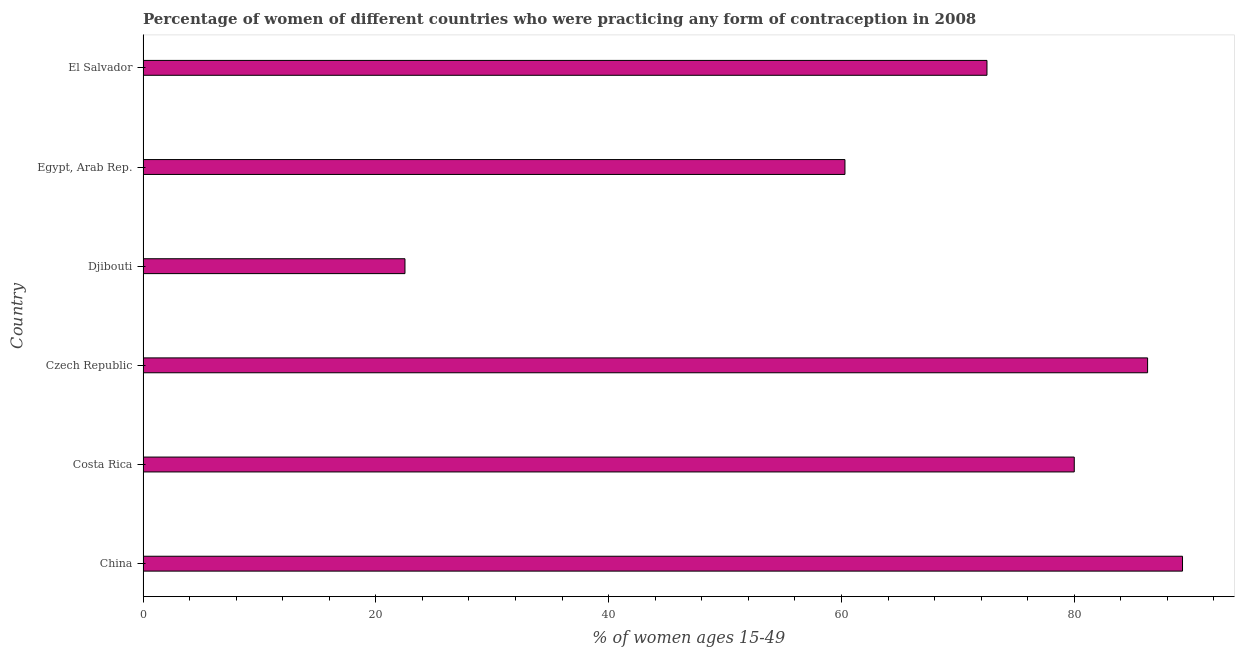Does the graph contain grids?
Offer a terse response. No. What is the title of the graph?
Offer a terse response. Percentage of women of different countries who were practicing any form of contraception in 2008. What is the label or title of the X-axis?
Make the answer very short. % of women ages 15-49. What is the label or title of the Y-axis?
Ensure brevity in your answer.  Country. Across all countries, what is the maximum contraceptive prevalence?
Your answer should be compact. 89.3. In which country was the contraceptive prevalence minimum?
Make the answer very short. Djibouti. What is the sum of the contraceptive prevalence?
Your answer should be very brief. 410.9. What is the average contraceptive prevalence per country?
Your response must be concise. 68.48. What is the median contraceptive prevalence?
Your answer should be very brief. 76.25. In how many countries, is the contraceptive prevalence greater than 4 %?
Provide a short and direct response. 6. What is the ratio of the contraceptive prevalence in Costa Rica to that in Czech Republic?
Provide a short and direct response. 0.93. Is the contraceptive prevalence in Costa Rica less than that in Djibouti?
Keep it short and to the point. No. What is the difference between the highest and the lowest contraceptive prevalence?
Make the answer very short. 66.8. How many bars are there?
Provide a short and direct response. 6. Are all the bars in the graph horizontal?
Keep it short and to the point. Yes. Are the values on the major ticks of X-axis written in scientific E-notation?
Offer a very short reply. No. What is the % of women ages 15-49 of China?
Provide a short and direct response. 89.3. What is the % of women ages 15-49 of Costa Rica?
Give a very brief answer. 80. What is the % of women ages 15-49 in Czech Republic?
Offer a terse response. 86.3. What is the % of women ages 15-49 of Djibouti?
Keep it short and to the point. 22.5. What is the % of women ages 15-49 of Egypt, Arab Rep.?
Give a very brief answer. 60.3. What is the % of women ages 15-49 in El Salvador?
Offer a terse response. 72.5. What is the difference between the % of women ages 15-49 in China and Costa Rica?
Keep it short and to the point. 9.3. What is the difference between the % of women ages 15-49 in China and Czech Republic?
Keep it short and to the point. 3. What is the difference between the % of women ages 15-49 in China and Djibouti?
Provide a short and direct response. 66.8. What is the difference between the % of women ages 15-49 in Costa Rica and Djibouti?
Your response must be concise. 57.5. What is the difference between the % of women ages 15-49 in Costa Rica and Egypt, Arab Rep.?
Provide a succinct answer. 19.7. What is the difference between the % of women ages 15-49 in Czech Republic and Djibouti?
Give a very brief answer. 63.8. What is the difference between the % of women ages 15-49 in Djibouti and Egypt, Arab Rep.?
Provide a succinct answer. -37.8. What is the difference between the % of women ages 15-49 in Egypt, Arab Rep. and El Salvador?
Give a very brief answer. -12.2. What is the ratio of the % of women ages 15-49 in China to that in Costa Rica?
Your response must be concise. 1.12. What is the ratio of the % of women ages 15-49 in China to that in Czech Republic?
Your answer should be very brief. 1.03. What is the ratio of the % of women ages 15-49 in China to that in Djibouti?
Keep it short and to the point. 3.97. What is the ratio of the % of women ages 15-49 in China to that in Egypt, Arab Rep.?
Keep it short and to the point. 1.48. What is the ratio of the % of women ages 15-49 in China to that in El Salvador?
Make the answer very short. 1.23. What is the ratio of the % of women ages 15-49 in Costa Rica to that in Czech Republic?
Keep it short and to the point. 0.93. What is the ratio of the % of women ages 15-49 in Costa Rica to that in Djibouti?
Provide a short and direct response. 3.56. What is the ratio of the % of women ages 15-49 in Costa Rica to that in Egypt, Arab Rep.?
Provide a succinct answer. 1.33. What is the ratio of the % of women ages 15-49 in Costa Rica to that in El Salvador?
Make the answer very short. 1.1. What is the ratio of the % of women ages 15-49 in Czech Republic to that in Djibouti?
Your answer should be compact. 3.84. What is the ratio of the % of women ages 15-49 in Czech Republic to that in Egypt, Arab Rep.?
Provide a succinct answer. 1.43. What is the ratio of the % of women ages 15-49 in Czech Republic to that in El Salvador?
Provide a short and direct response. 1.19. What is the ratio of the % of women ages 15-49 in Djibouti to that in Egypt, Arab Rep.?
Provide a short and direct response. 0.37. What is the ratio of the % of women ages 15-49 in Djibouti to that in El Salvador?
Offer a very short reply. 0.31. What is the ratio of the % of women ages 15-49 in Egypt, Arab Rep. to that in El Salvador?
Your answer should be very brief. 0.83. 